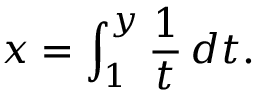Convert formula to latex. <formula><loc_0><loc_0><loc_500><loc_500>x = \int _ { 1 } ^ { y } { \frac { 1 } { t } } \, d t .</formula> 